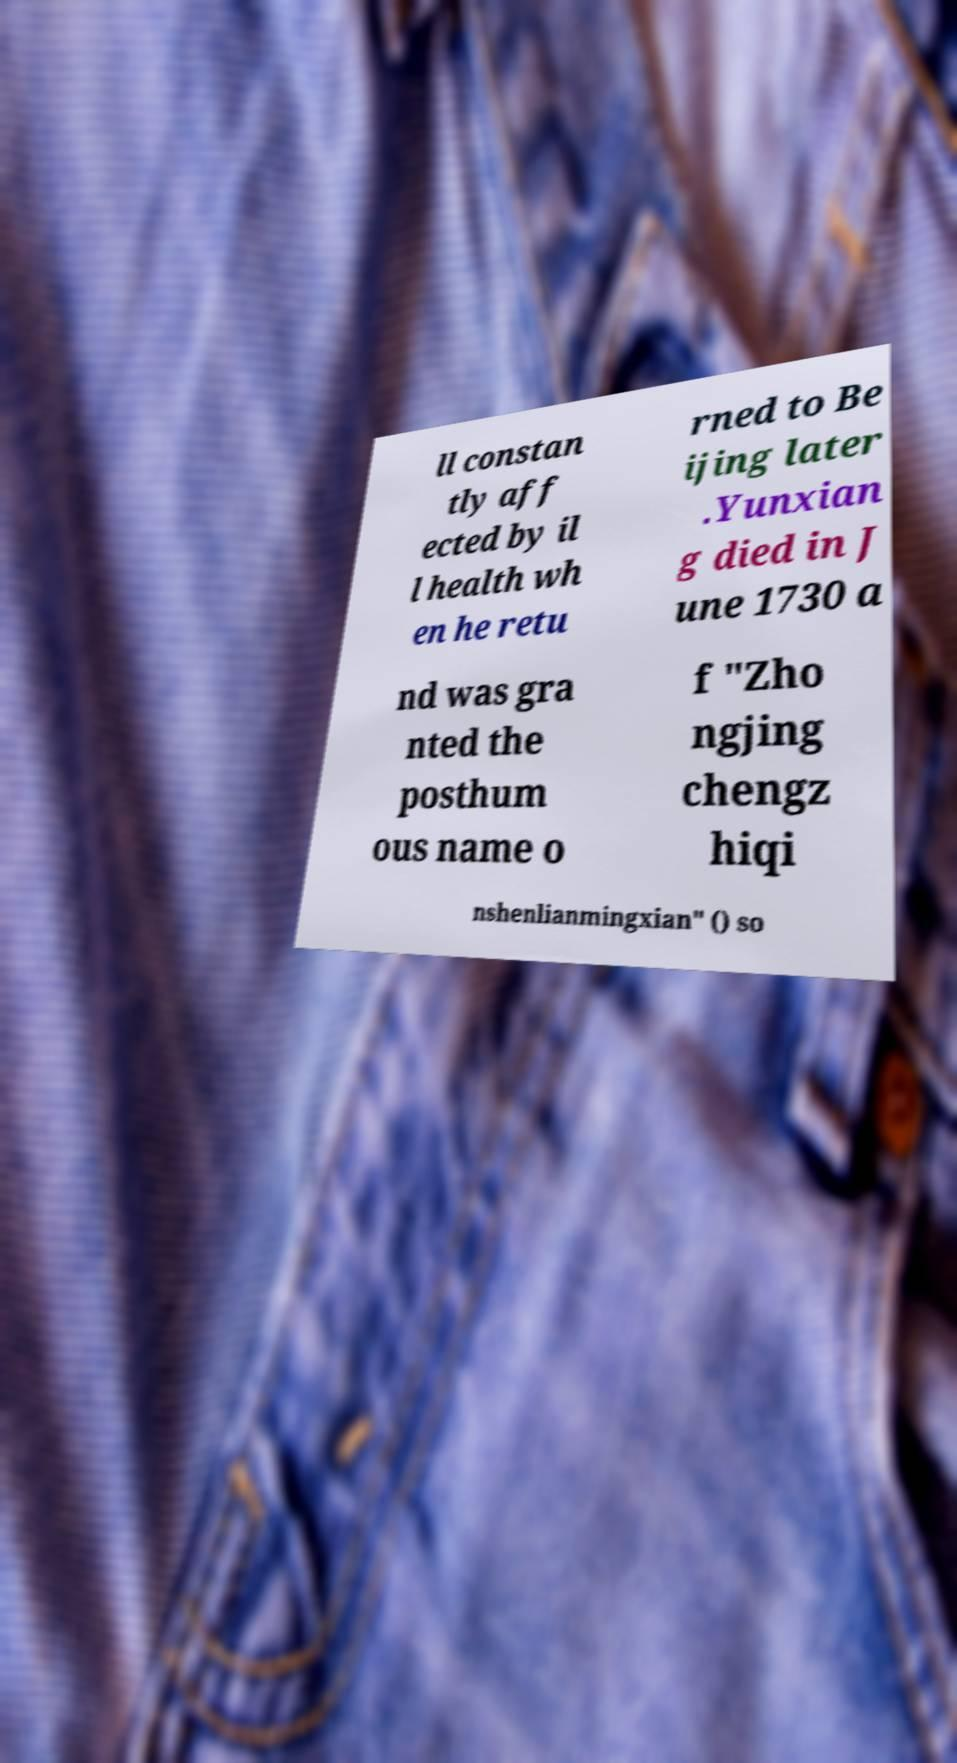There's text embedded in this image that I need extracted. Can you transcribe it verbatim? ll constan tly aff ected by il l health wh en he retu rned to Be ijing later .Yunxian g died in J une 1730 a nd was gra nted the posthum ous name o f "Zho ngjing chengz hiqi nshenlianmingxian" () so 